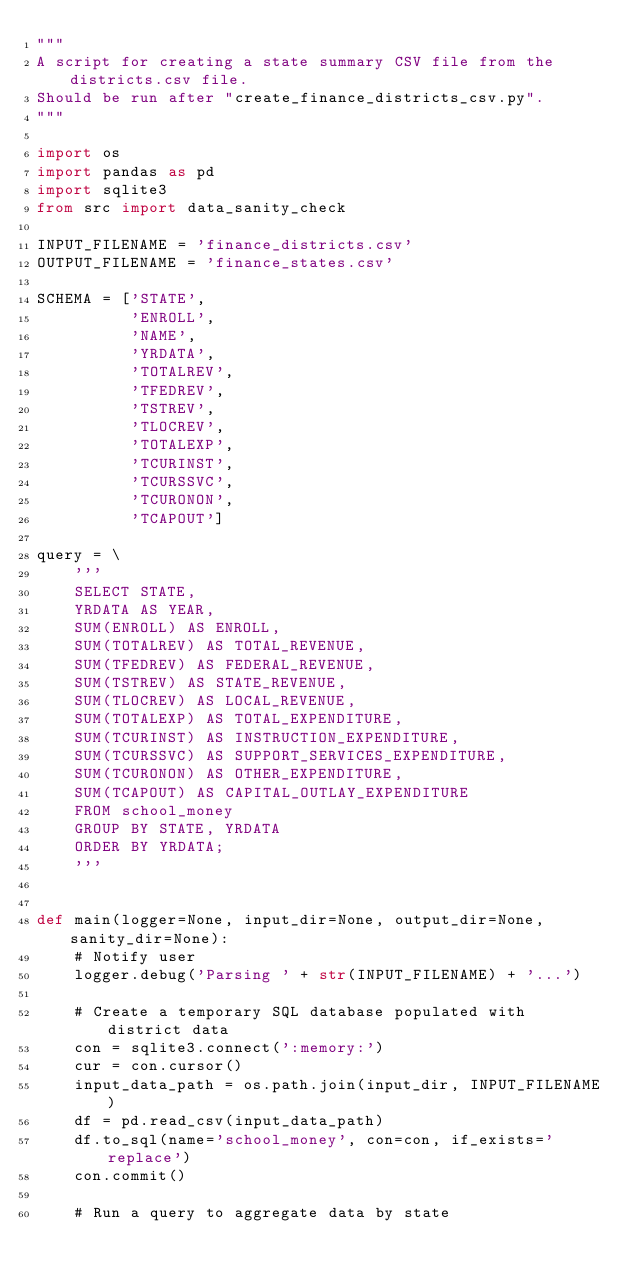Convert code to text. <code><loc_0><loc_0><loc_500><loc_500><_Python_>"""
A script for creating a state summary CSV file from the districts.csv file.
Should be run after "create_finance_districts_csv.py".
"""

import os
import pandas as pd
import sqlite3
from src import data_sanity_check

INPUT_FILENAME = 'finance_districts.csv'
OUTPUT_FILENAME = 'finance_states.csv'

SCHEMA = ['STATE',
          'ENROLL',
          'NAME',
          'YRDATA',
          'TOTALREV',
          'TFEDREV',
          'TSTREV',
          'TLOCREV',
          'TOTALEXP',
          'TCURINST',
          'TCURSSVC',
          'TCURONON',
          'TCAPOUT']

query = \
    '''
    SELECT STATE,
    YRDATA AS YEAR,
    SUM(ENROLL) AS ENROLL,
    SUM(TOTALREV) AS TOTAL_REVENUE,
    SUM(TFEDREV) AS FEDERAL_REVENUE,
    SUM(TSTREV) AS STATE_REVENUE,
    SUM(TLOCREV) AS LOCAL_REVENUE,
    SUM(TOTALEXP) AS TOTAL_EXPENDITURE,
    SUM(TCURINST) AS INSTRUCTION_EXPENDITURE,
    SUM(TCURSSVC) AS SUPPORT_SERVICES_EXPENDITURE,
    SUM(TCURONON) AS OTHER_EXPENDITURE,
    SUM(TCAPOUT) AS CAPITAL_OUTLAY_EXPENDITURE
    FROM school_money
    GROUP BY STATE, YRDATA
    ORDER BY YRDATA;
    '''


def main(logger=None, input_dir=None, output_dir=None, sanity_dir=None):
    # Notify user
    logger.debug('Parsing ' + str(INPUT_FILENAME) + '...')

    # Create a temporary SQL database populated with district data
    con = sqlite3.connect(':memory:')
    cur = con.cursor()
    input_data_path = os.path.join(input_dir, INPUT_FILENAME)
    df = pd.read_csv(input_data_path)
    df.to_sql(name='school_money', con=con, if_exists='replace')
    con.commit()

    # Run a query to aggregate data by state</code> 